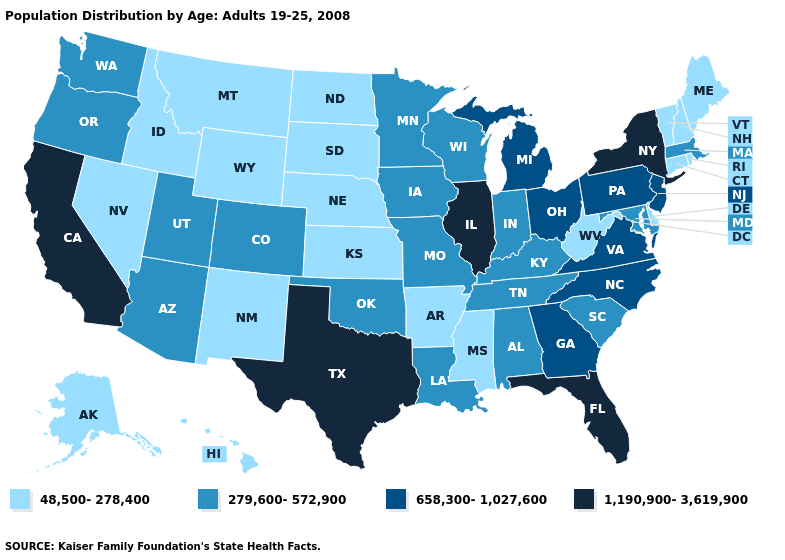Which states have the lowest value in the Northeast?
Keep it brief. Connecticut, Maine, New Hampshire, Rhode Island, Vermont. Name the states that have a value in the range 1,190,900-3,619,900?
Keep it brief. California, Florida, Illinois, New York, Texas. Name the states that have a value in the range 1,190,900-3,619,900?
Write a very short answer. California, Florida, Illinois, New York, Texas. What is the value of Arizona?
Write a very short answer. 279,600-572,900. Does Hawaii have a lower value than Nebraska?
Be succinct. No. Which states hav the highest value in the West?
Keep it brief. California. Name the states that have a value in the range 48,500-278,400?
Answer briefly. Alaska, Arkansas, Connecticut, Delaware, Hawaii, Idaho, Kansas, Maine, Mississippi, Montana, Nebraska, Nevada, New Hampshire, New Mexico, North Dakota, Rhode Island, South Dakota, Vermont, West Virginia, Wyoming. Name the states that have a value in the range 658,300-1,027,600?
Short answer required. Georgia, Michigan, New Jersey, North Carolina, Ohio, Pennsylvania, Virginia. What is the lowest value in states that border Wyoming?
Answer briefly. 48,500-278,400. Name the states that have a value in the range 279,600-572,900?
Be succinct. Alabama, Arizona, Colorado, Indiana, Iowa, Kentucky, Louisiana, Maryland, Massachusetts, Minnesota, Missouri, Oklahoma, Oregon, South Carolina, Tennessee, Utah, Washington, Wisconsin. Name the states that have a value in the range 1,190,900-3,619,900?
Concise answer only. California, Florida, Illinois, New York, Texas. Name the states that have a value in the range 279,600-572,900?
Quick response, please. Alabama, Arizona, Colorado, Indiana, Iowa, Kentucky, Louisiana, Maryland, Massachusetts, Minnesota, Missouri, Oklahoma, Oregon, South Carolina, Tennessee, Utah, Washington, Wisconsin. What is the value of Utah?
Be succinct. 279,600-572,900. Name the states that have a value in the range 1,190,900-3,619,900?
Answer briefly. California, Florida, Illinois, New York, Texas. What is the lowest value in the USA?
Keep it brief. 48,500-278,400. 